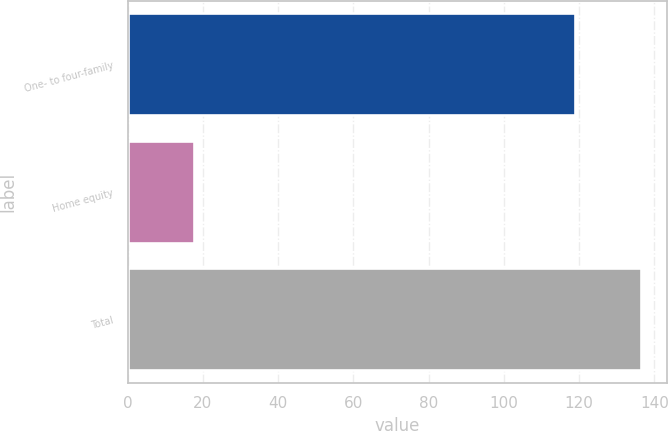<chart> <loc_0><loc_0><loc_500><loc_500><bar_chart><fcel>One- to four-family<fcel>Home equity<fcel>Total<nl><fcel>118.8<fcel>17.6<fcel>136.4<nl></chart> 